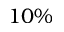Convert formula to latex. <formula><loc_0><loc_0><loc_500><loc_500>1 0 \%</formula> 